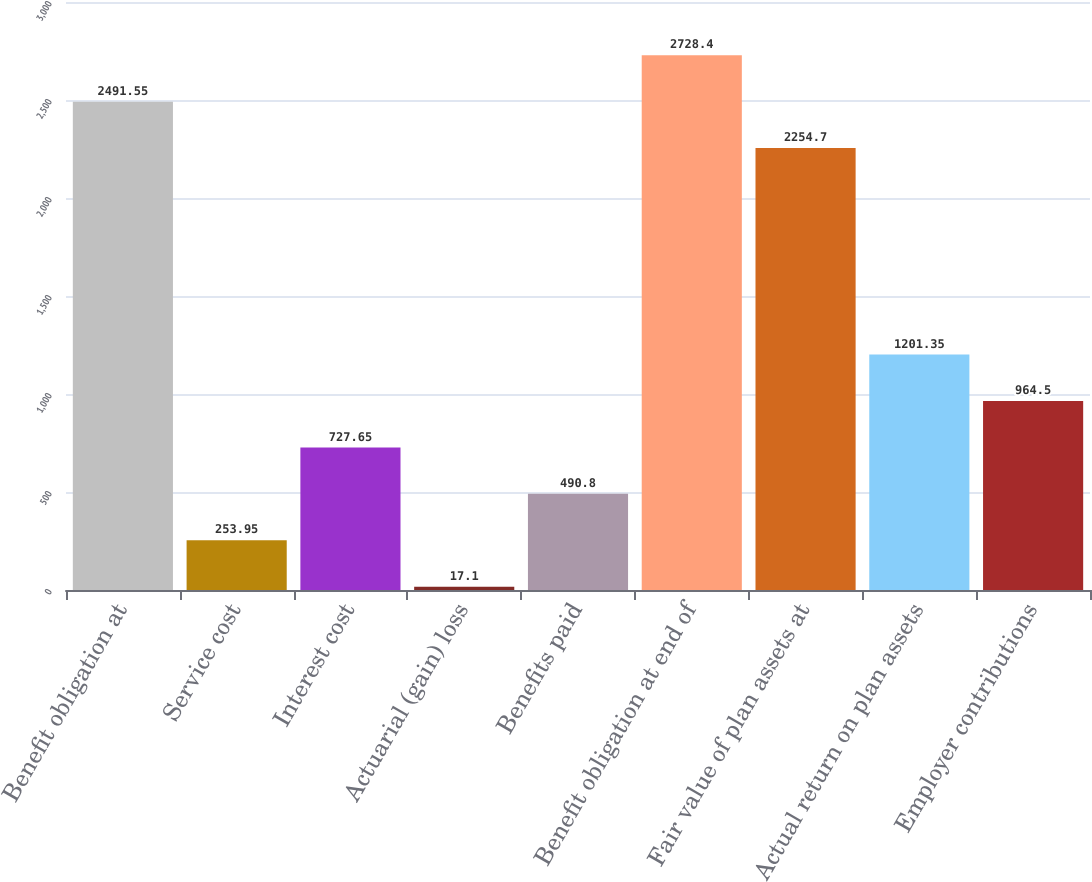Convert chart. <chart><loc_0><loc_0><loc_500><loc_500><bar_chart><fcel>Benefit obligation at<fcel>Service cost<fcel>Interest cost<fcel>Actuarial (gain) loss<fcel>Benefits paid<fcel>Benefit obligation at end of<fcel>Fair value of plan assets at<fcel>Actual return on plan assets<fcel>Employer contributions<nl><fcel>2491.55<fcel>253.95<fcel>727.65<fcel>17.1<fcel>490.8<fcel>2728.4<fcel>2254.7<fcel>1201.35<fcel>964.5<nl></chart> 